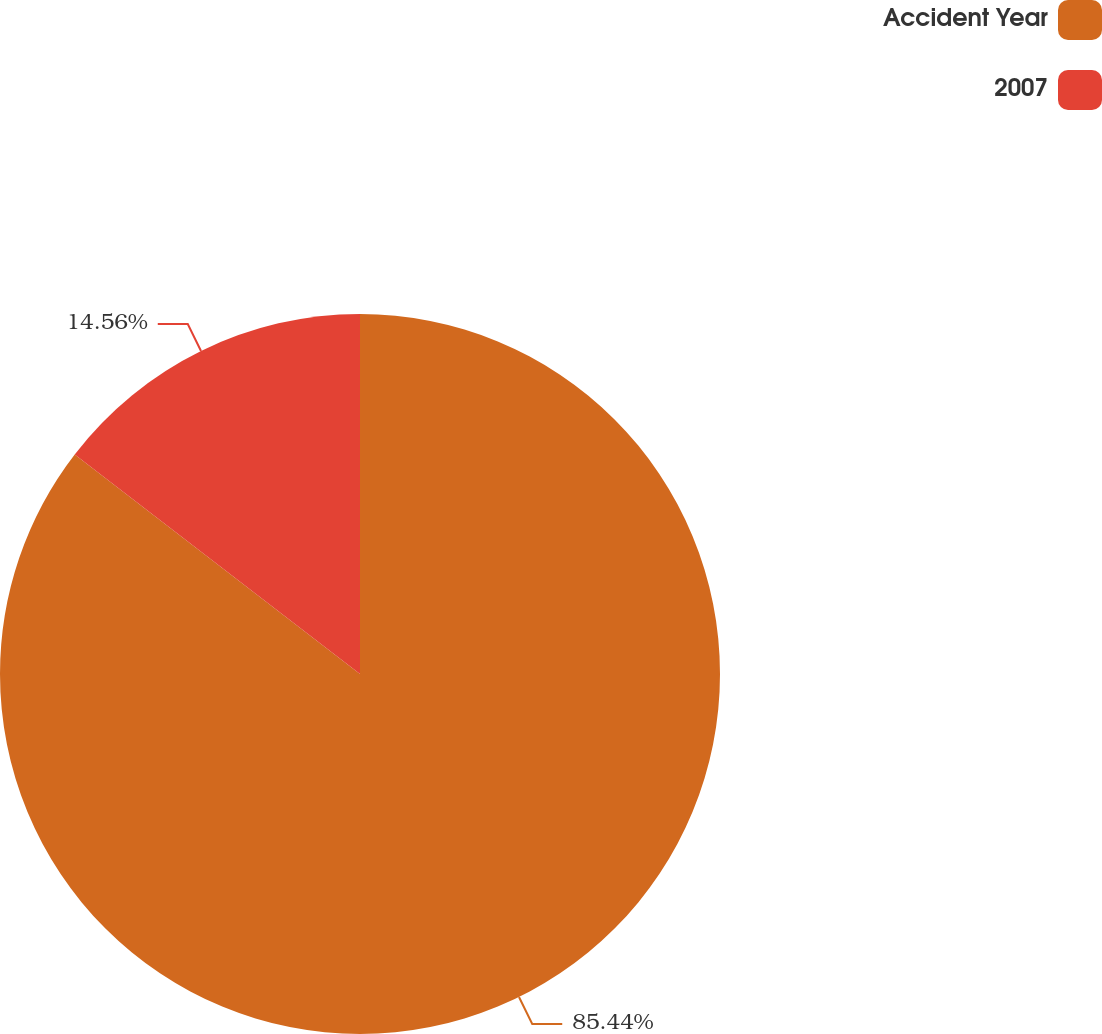Convert chart to OTSL. <chart><loc_0><loc_0><loc_500><loc_500><pie_chart><fcel>Accident Year<fcel>2007<nl><fcel>85.44%<fcel>14.56%<nl></chart> 